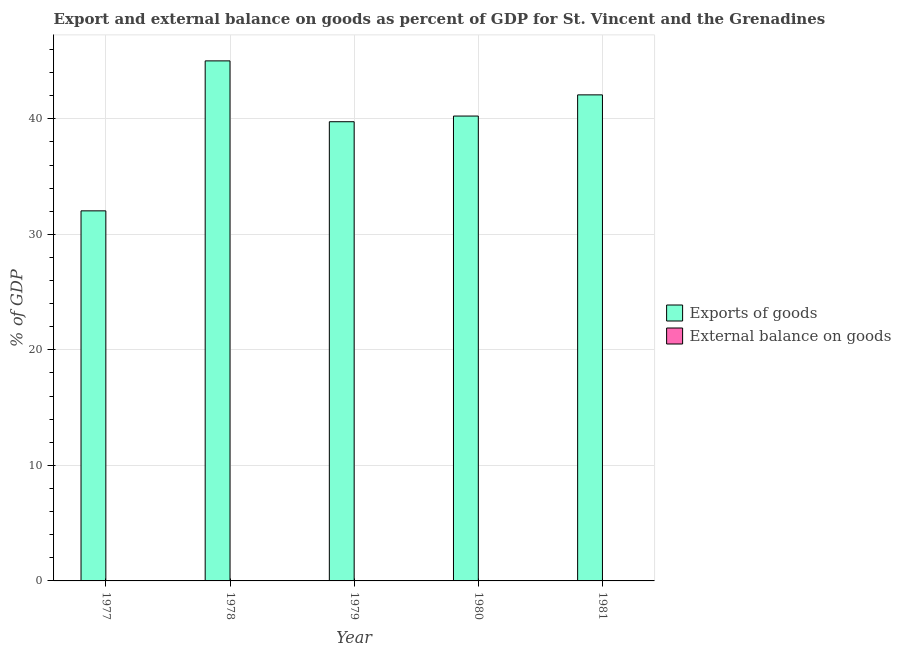Are the number of bars on each tick of the X-axis equal?
Offer a terse response. Yes. How many bars are there on the 2nd tick from the right?
Your answer should be compact. 1. What is the label of the 3rd group of bars from the left?
Ensure brevity in your answer.  1979. In how many cases, is the number of bars for a given year not equal to the number of legend labels?
Offer a very short reply. 5. What is the export of goods as percentage of gdp in 1978?
Ensure brevity in your answer.  45.02. Across all years, what is the maximum export of goods as percentage of gdp?
Give a very brief answer. 45.02. Across all years, what is the minimum export of goods as percentage of gdp?
Offer a very short reply. 32.04. In which year was the export of goods as percentage of gdp maximum?
Your answer should be compact. 1978. What is the total export of goods as percentage of gdp in the graph?
Give a very brief answer. 199.13. What is the difference between the export of goods as percentage of gdp in 1977 and that in 1978?
Ensure brevity in your answer.  -12.98. What is the difference between the export of goods as percentage of gdp in 1981 and the external balance on goods as percentage of gdp in 1978?
Your response must be concise. -2.94. What is the average export of goods as percentage of gdp per year?
Your answer should be compact. 39.83. Is the export of goods as percentage of gdp in 1977 less than that in 1979?
Keep it short and to the point. Yes. Is the difference between the export of goods as percentage of gdp in 1980 and 1981 greater than the difference between the external balance on goods as percentage of gdp in 1980 and 1981?
Offer a very short reply. No. What is the difference between the highest and the second highest export of goods as percentage of gdp?
Offer a terse response. 2.94. What is the difference between the highest and the lowest export of goods as percentage of gdp?
Provide a succinct answer. 12.98. What is the difference between two consecutive major ticks on the Y-axis?
Make the answer very short. 10. Are the values on the major ticks of Y-axis written in scientific E-notation?
Your answer should be very brief. No. Does the graph contain any zero values?
Your answer should be compact. Yes. How many legend labels are there?
Your answer should be compact. 2. What is the title of the graph?
Give a very brief answer. Export and external balance on goods as percent of GDP for St. Vincent and the Grenadines. Does "Males" appear as one of the legend labels in the graph?
Provide a short and direct response. No. What is the label or title of the Y-axis?
Provide a short and direct response. % of GDP. What is the % of GDP of Exports of goods in 1977?
Give a very brief answer. 32.04. What is the % of GDP of External balance on goods in 1977?
Keep it short and to the point. 0. What is the % of GDP of Exports of goods in 1978?
Make the answer very short. 45.02. What is the % of GDP of Exports of goods in 1979?
Ensure brevity in your answer.  39.75. What is the % of GDP of Exports of goods in 1980?
Your answer should be compact. 40.24. What is the % of GDP in External balance on goods in 1980?
Make the answer very short. 0. What is the % of GDP in Exports of goods in 1981?
Provide a succinct answer. 42.08. Across all years, what is the maximum % of GDP of Exports of goods?
Give a very brief answer. 45.02. Across all years, what is the minimum % of GDP of Exports of goods?
Keep it short and to the point. 32.04. What is the total % of GDP of Exports of goods in the graph?
Keep it short and to the point. 199.13. What is the difference between the % of GDP of Exports of goods in 1977 and that in 1978?
Make the answer very short. -12.98. What is the difference between the % of GDP of Exports of goods in 1977 and that in 1979?
Offer a terse response. -7.72. What is the difference between the % of GDP of Exports of goods in 1977 and that in 1980?
Provide a short and direct response. -8.21. What is the difference between the % of GDP of Exports of goods in 1977 and that in 1981?
Your answer should be very brief. -10.04. What is the difference between the % of GDP in Exports of goods in 1978 and that in 1979?
Offer a terse response. 5.27. What is the difference between the % of GDP in Exports of goods in 1978 and that in 1980?
Your response must be concise. 4.78. What is the difference between the % of GDP of Exports of goods in 1978 and that in 1981?
Your response must be concise. 2.94. What is the difference between the % of GDP in Exports of goods in 1979 and that in 1980?
Your response must be concise. -0.49. What is the difference between the % of GDP in Exports of goods in 1979 and that in 1981?
Your answer should be compact. -2.32. What is the difference between the % of GDP of Exports of goods in 1980 and that in 1981?
Ensure brevity in your answer.  -1.83. What is the average % of GDP in Exports of goods per year?
Make the answer very short. 39.83. What is the ratio of the % of GDP of Exports of goods in 1977 to that in 1978?
Your response must be concise. 0.71. What is the ratio of the % of GDP in Exports of goods in 1977 to that in 1979?
Provide a succinct answer. 0.81. What is the ratio of the % of GDP in Exports of goods in 1977 to that in 1980?
Offer a very short reply. 0.8. What is the ratio of the % of GDP in Exports of goods in 1977 to that in 1981?
Your response must be concise. 0.76. What is the ratio of the % of GDP in Exports of goods in 1978 to that in 1979?
Keep it short and to the point. 1.13. What is the ratio of the % of GDP of Exports of goods in 1978 to that in 1980?
Provide a short and direct response. 1.12. What is the ratio of the % of GDP of Exports of goods in 1978 to that in 1981?
Your answer should be very brief. 1.07. What is the ratio of the % of GDP in Exports of goods in 1979 to that in 1980?
Provide a succinct answer. 0.99. What is the ratio of the % of GDP in Exports of goods in 1979 to that in 1981?
Your response must be concise. 0.94. What is the ratio of the % of GDP in Exports of goods in 1980 to that in 1981?
Your answer should be compact. 0.96. What is the difference between the highest and the second highest % of GDP of Exports of goods?
Your answer should be very brief. 2.94. What is the difference between the highest and the lowest % of GDP of Exports of goods?
Your answer should be compact. 12.98. 